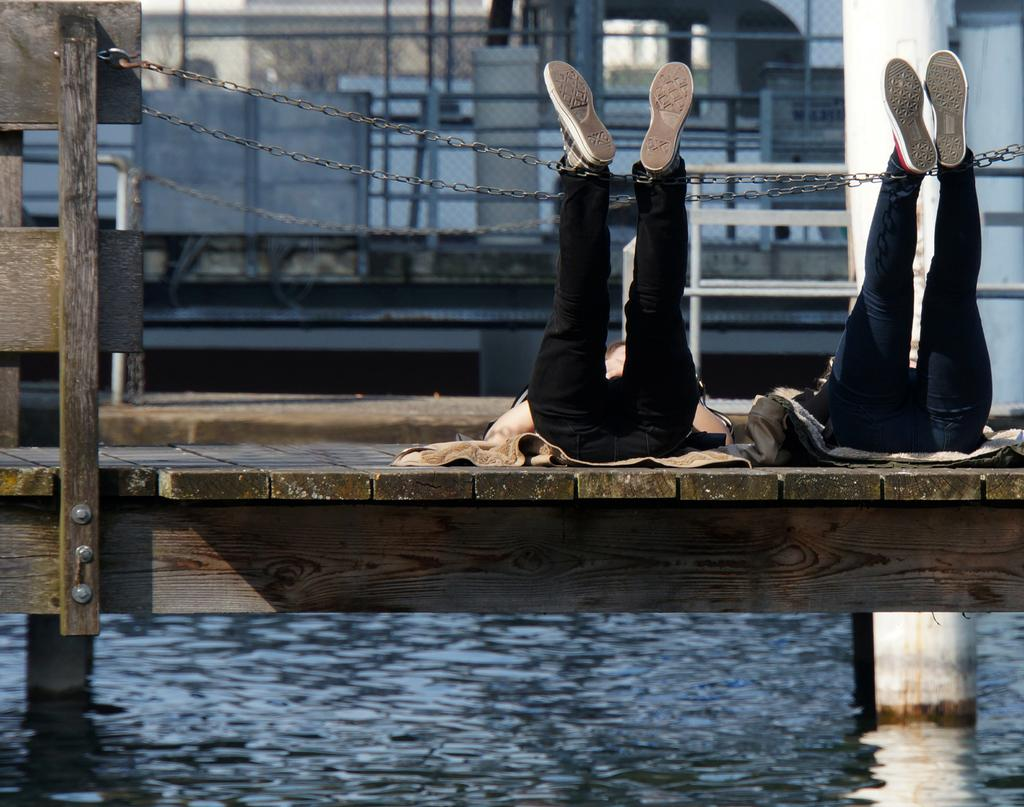What is the primary element visible in the image? There is water in the image. What structures are present near the water? There are wooden piers in the image. What are the two persons in the image doing? Two persons are lying on the wooden piers. What type of barrier can be seen in the image? There is a fence in the image. What type of material is used for the chains in the image? Chains are present in the image, but the material is not specified. Can you describe any other objects in the image? There are other unspecified objects in the image. What type of authority figure can be seen in the image? There is no authority figure present in the image. Can you describe the bite of the wooden piers in the image? The wooden piers in the image are not associated with a bite, as they are inanimate objects. 